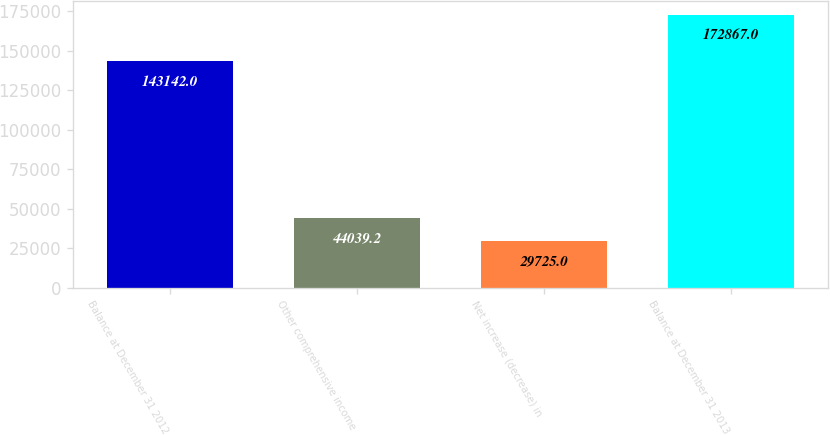Convert chart to OTSL. <chart><loc_0><loc_0><loc_500><loc_500><bar_chart><fcel>Balance at December 31 2012<fcel>Other comprehensive income<fcel>Net increase (decrease) in<fcel>Balance at December 31 2013<nl><fcel>143142<fcel>44039.2<fcel>29725<fcel>172867<nl></chart> 